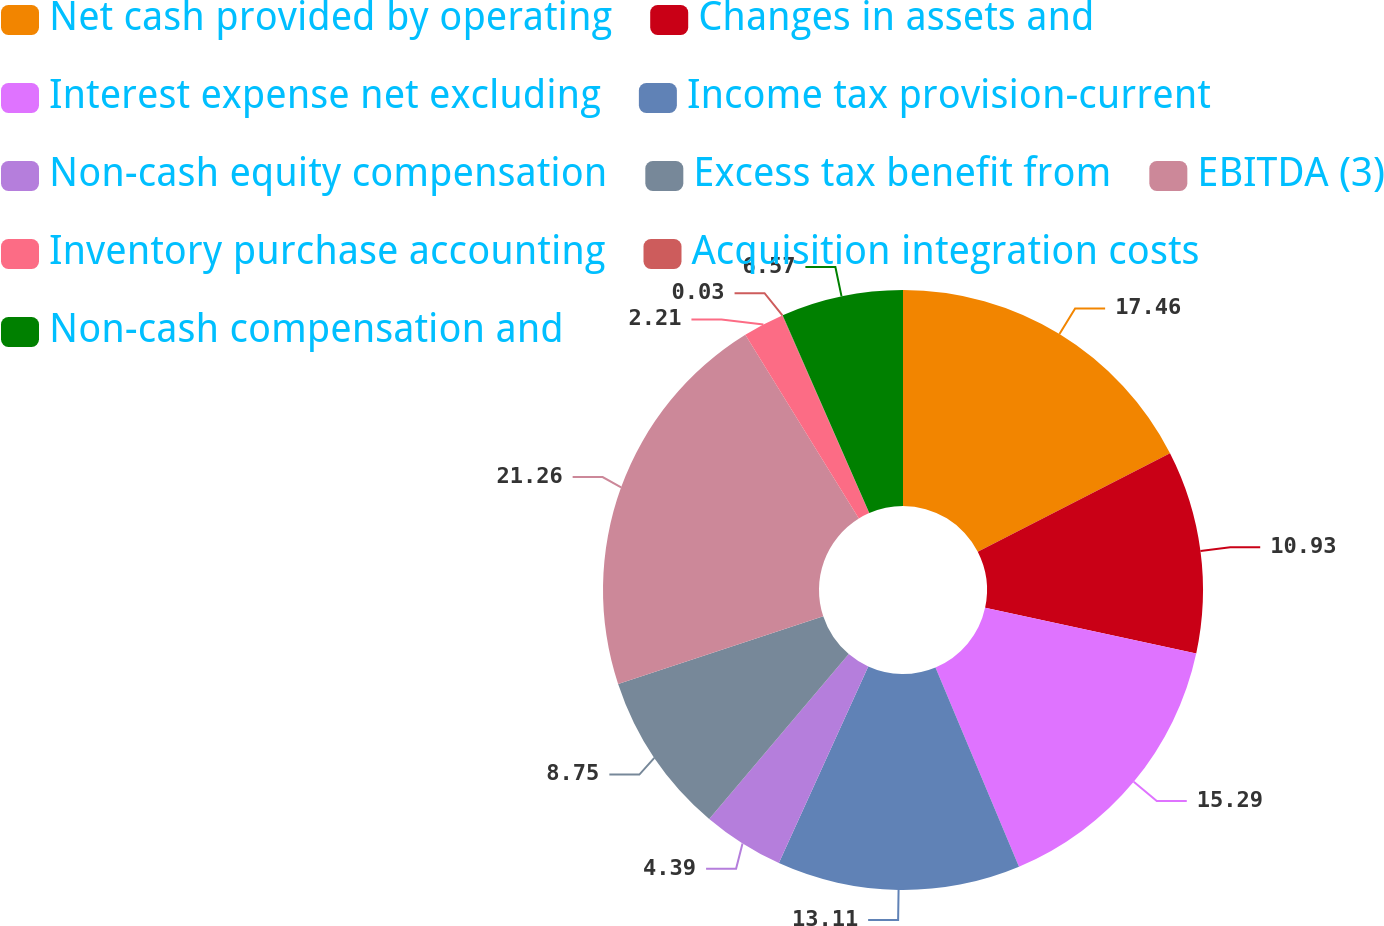<chart> <loc_0><loc_0><loc_500><loc_500><pie_chart><fcel>Net cash provided by operating<fcel>Changes in assets and<fcel>Interest expense net excluding<fcel>Income tax provision-current<fcel>Non-cash equity compensation<fcel>Excess tax benefit from<fcel>EBITDA (3)<fcel>Inventory purchase accounting<fcel>Acquisition integration costs<fcel>Non-cash compensation and<nl><fcel>17.47%<fcel>10.93%<fcel>15.29%<fcel>13.11%<fcel>4.39%<fcel>8.75%<fcel>21.27%<fcel>2.21%<fcel>0.03%<fcel>6.57%<nl></chart> 